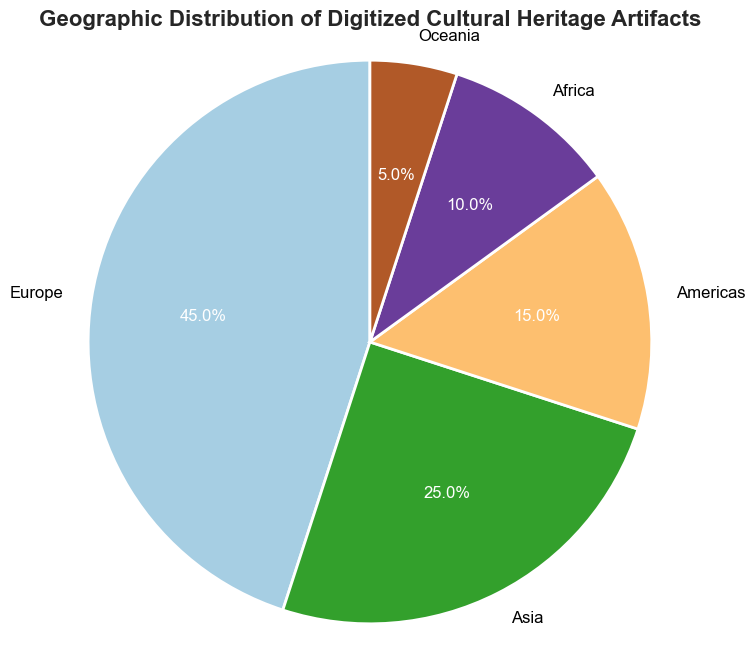What is the total percentage of digitized cultural heritage artifacts from Europe and Asia? To find the total percentage of Europe and Asia, you need to add their individual percentages: 45% (Europe) + 25% (Asia) = 70%
Answer: 70% Which region has the smallest percentage of digitized cultural heritage artifacts? By looking at the pie chart, the region with the smallest percentage is Oceania with 5%.
Answer: Oceania Is the percentage of artifacts from the Americas greater than that from Africa? By comparing the percentages, the Americas have 15% and Africa has 10%, so the Americas have a greater percentage than Africa.
Answer: Yes What is the difference in percentage between Europe and the Americas? To find the difference, subtract the percentage of the Americas from Europe's: 45% - 15% = 30%
Answer: 30% If you combine the percentages of Africa and Oceania, will the total be greater than that of Asia? Combining Africa and Oceania gives 10% + 5% = 15%. Asia has 25%, so 15% is not greater than 25%.
Answer: No Which regions have percentages that are less than 20%? By examining the chart, the regions with percentages less than 20% are the Americas (15%), Africa (10%), and Oceania (5%).
Answer: Americas, Africa, Oceania How much more significant is Europe’s percentage than Oceania’s? The difference is calculated by subtracting Oceania's percentage from Europe's: 45% - 5% = 40%
Answer: 40% What is the average percentage of digitized cultural heritage artifacts listed in the pie chart? There are five regions. The average is calculated by summing the percentages and then dividing by the number of regions: (45% + 25% + 15% + 10% + 5%) / 5 = 100% / 5 = 20%
Answer: 20% Which color is used to represent Europe in the pie chart? Since the question requires visual inspection, you need to look at the pie chart and note the color used for the Europe section. (Note: Mention the color observed)
Answer: [Color observed in the chart] How much more significant is Europe's percentage compared to Americas and Oceania combined? First, combine the percentages of the Americas and Oceania: 15% + 5% = 20%. Then find the difference between Europe and the combined value: 45% - 20% = 25%
Answer: 25% 